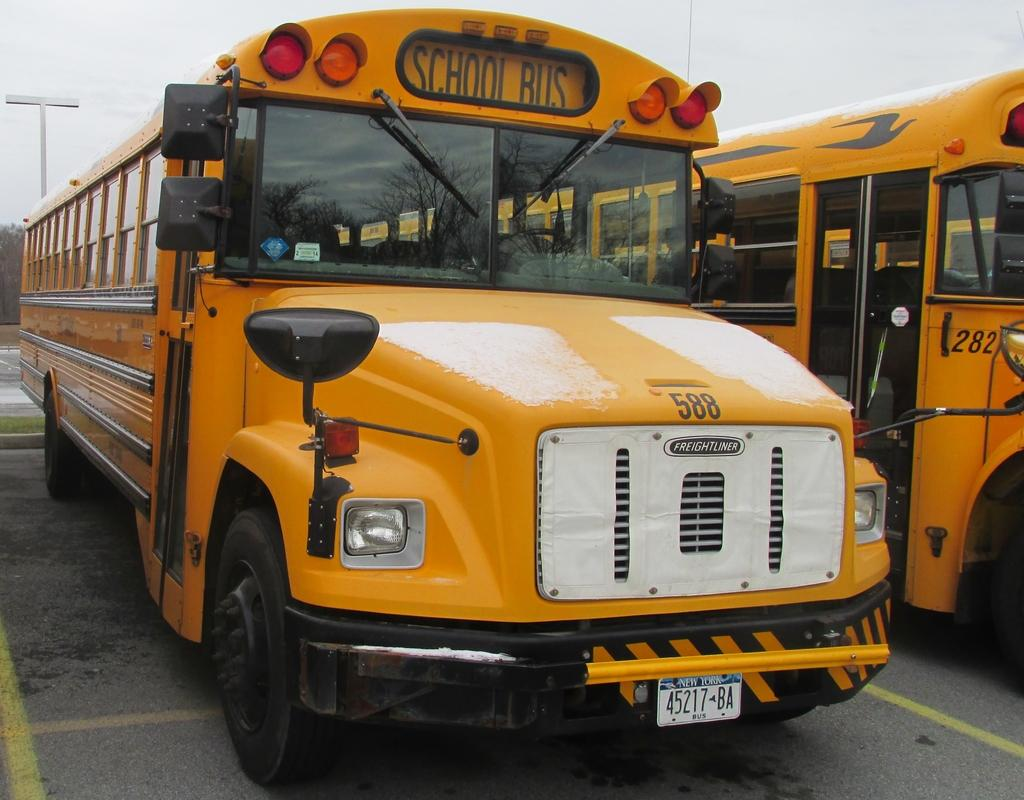What type of objects are present in the image? There are vehicles in the image. What colors are the vehicles? The vehicles are in yellow and black colors. What else can be seen in the image besides the vehicles? There is a pole in the image. What is visible in the background of the image? The sky is visible in the image. What type of plate is placed on the front of the vehicle in the image? There is no plate visible on the front of the vehicle in the image. Can you describe the middle part of the vehicle in the image? The provided facts do not give any information about the middle part of the vehicle, so it cannot be described. 